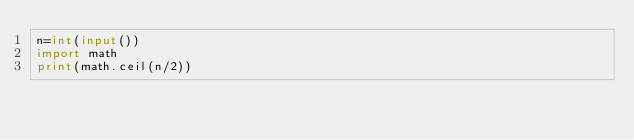Convert code to text. <code><loc_0><loc_0><loc_500><loc_500><_Python_>n=int(input())
import math
print(math.ceil(n/2))</code> 